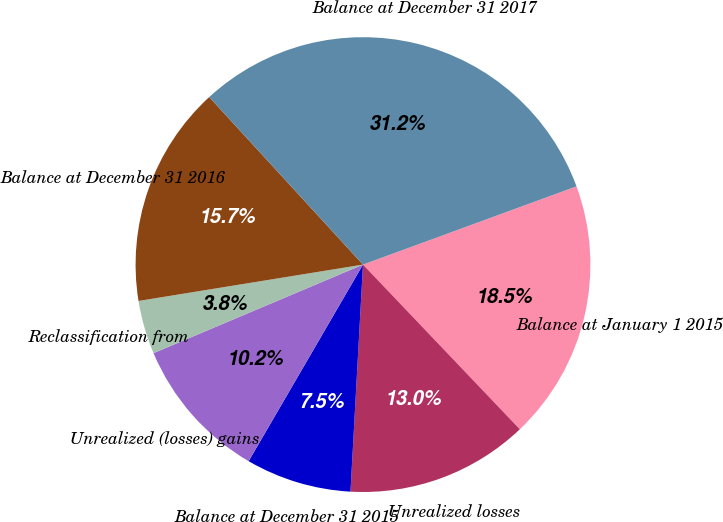Convert chart to OTSL. <chart><loc_0><loc_0><loc_500><loc_500><pie_chart><fcel>Balance at January 1 2015<fcel>Unrealized losses<fcel>Balance at December 31 2015<fcel>Unrealized (losses) gains<fcel>Reclassification from<fcel>Balance at December 31 2016<fcel>Balance at December 31 2017<nl><fcel>18.48%<fcel>12.99%<fcel>7.51%<fcel>10.25%<fcel>3.81%<fcel>15.74%<fcel>31.23%<nl></chart> 